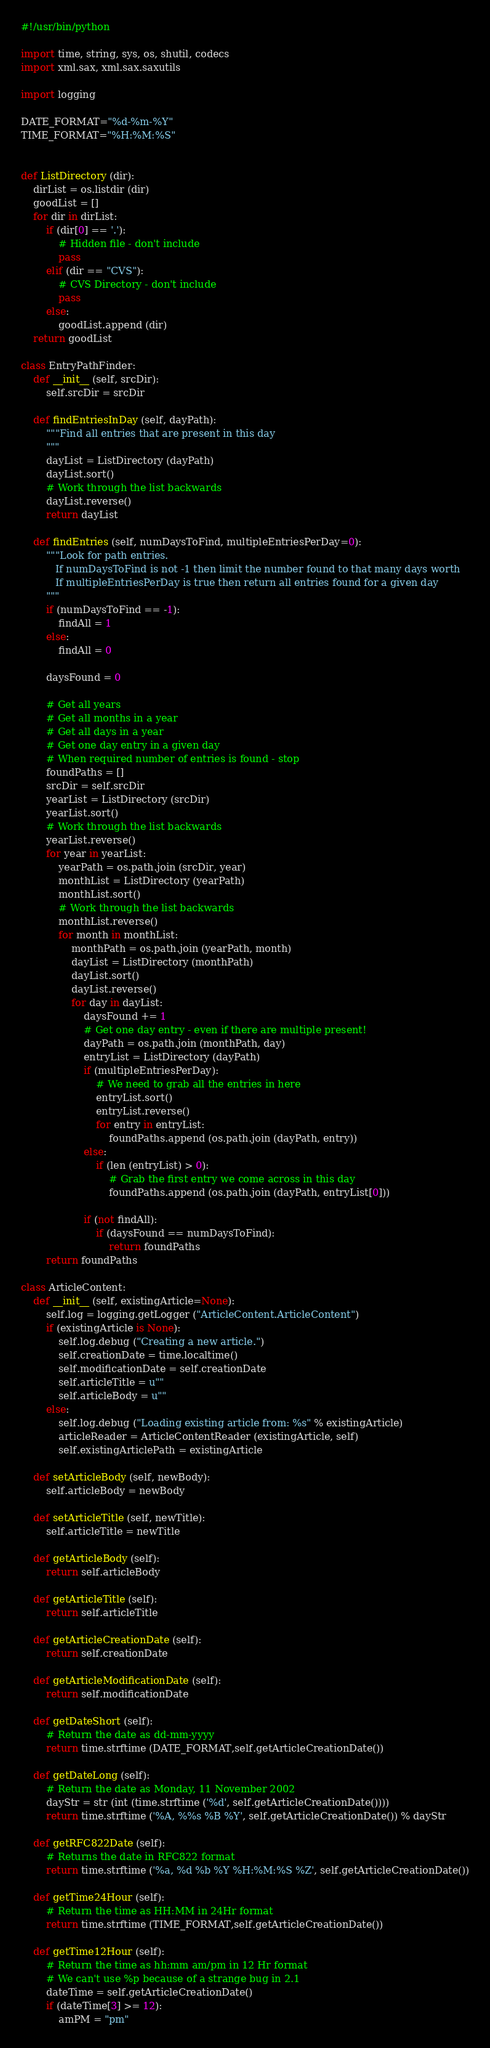Convert code to text. <code><loc_0><loc_0><loc_500><loc_500><_Python_>#!/usr/bin/python

import time, string, sys, os, shutil, codecs
import xml.sax, xml.sax.saxutils

import logging

DATE_FORMAT="%d-%m-%Y"
TIME_FORMAT="%H:%M:%S"


def ListDirectory (dir):
	dirList = os.listdir (dir)
	goodList = []
	for dir in dirList:
		if (dir[0] == '.'):
			# Hidden file - don't include
			pass
		elif (dir == "CVS"):
			# CVS Directory - don't include
			pass
		else:
			goodList.append (dir)
	return goodList
	
class EntryPathFinder:
	def __init__ (self, srcDir):
		self.srcDir = srcDir
		
	def findEntriesInDay (self, dayPath):
		"""Find all entries that are present in this day
		"""
		dayList = ListDirectory (dayPath)
		dayList.sort()
		# Work through the list backwards
		dayList.reverse()
		return dayList

	def findEntries (self, numDaysToFind, multipleEntriesPerDay=0):
		"""Look for path entries.
		   If numDaysToFind is not -1 then limit the number found to that many days worth
		   If multipleEntriesPerDay is true then return all entries found for a given day
		"""
		if (numDaysToFind == -1):
			findAll = 1
		else:
			findAll = 0
			
		daysFound = 0
			
		# Get all years
		# Get all months in a year
		# Get all days in a year
		# Get one day entry in a given day
		# When required number of entries is found - stop
		foundPaths = []
		srcDir = self.srcDir
		yearList = ListDirectory (srcDir)
		yearList.sort()
		# Work through the list backwards
		yearList.reverse()
		for year in yearList:
			yearPath = os.path.join (srcDir, year)
			monthList = ListDirectory (yearPath)
			monthList.sort()
			# Work through the list backwards
			monthList.reverse()
			for month in monthList:
				monthPath = os.path.join (yearPath, month)
				dayList = ListDirectory (monthPath)
				dayList.sort()
				dayList.reverse()
				for day in dayList:
					daysFound += 1
					# Get one day entry - even if there are multiple present!
					dayPath = os.path.join (monthPath, day)
					entryList = ListDirectory (dayPath)
					if (multipleEntriesPerDay):
						# We need to grab all the entries in here
						entryList.sort()
						entryList.reverse()
						for entry in entryList:
							foundPaths.append (os.path.join (dayPath, entry))
					else:						
						if (len (entryList) > 0):
							# Grab the first entry we come across in this day
							foundPaths.append (os.path.join (dayPath, entryList[0]))
						
					if (not findAll):
						if (daysFound == numDaysToFind):
							return foundPaths
		return foundPaths

class ArticleContent:
	def __init__ (self, existingArticle=None):
		self.log = logging.getLogger ("ArticleContent.ArticleContent")
		if (existingArticle is None):
			self.log.debug ("Creating a new article.")
			self.creationDate = time.localtime()
			self.modificationDate = self.creationDate
			self.articleTitle = u""
			self.articleBody = u""
		else:
			self.log.debug ("Loading existing article from: %s" % existingArticle)
			articleReader = ArticleContentReader (existingArticle, self)
			self.existingArticlePath = existingArticle
			
	def setArticleBody (self, newBody):
		self.articleBody = newBody
		
	def setArticleTitle (self, newTitle):
		self.articleTitle = newTitle
		
	def getArticleBody (self):
		return self.articleBody
		
	def getArticleTitle (self):
		return self.articleTitle
		
	def getArticleCreationDate (self):
		return self.creationDate
		
	def getArticleModificationDate (self):
		return self.modificationDate
		
	def getDateShort (self):
		# Return the date as dd-mm-yyyy
		return time.strftime (DATE_FORMAT,self.getArticleCreationDate())
		
	def getDateLong (self):
		# Return the date as Monday, 11 November 2002
		dayStr = str (int (time.strftime ('%d', self.getArticleCreationDate())))
		return time.strftime ('%A, %%s %B %Y', self.getArticleCreationDate()) % dayStr
		
	def getRFC822Date (self):
		# Returns the date in RFC822 format
		return time.strftime ('%a, %d %b %Y %H:%M:%S %Z', self.getArticleCreationDate())
		
	def getTime24Hour (self):
		# Return the time as HH:MM in 24Hr format
		return time.strftime (TIME_FORMAT,self.getArticleCreationDate())
		
	def getTime12Hour (self):
		# Return the time as hh:mm am/pm in 12 Hr format
		# We can't use %p because of a strange bug in 2.1
		dateTime = self.getArticleCreationDate()
		if (dateTime[3] >= 12):
			amPM = "pm"</code> 